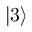<formula> <loc_0><loc_0><loc_500><loc_500>\left | 3 \right ></formula> 